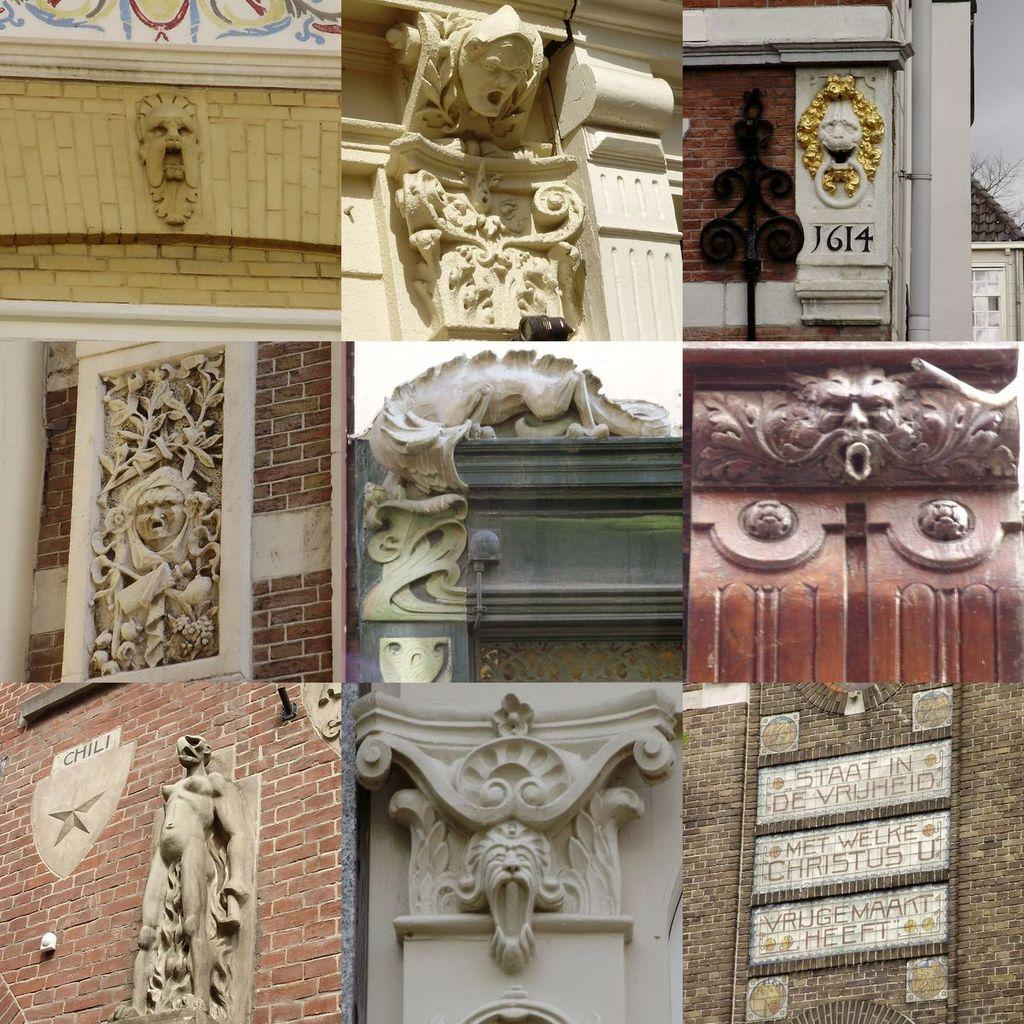What type of artwork is featured in the image? There are collages of photos and sculptures on the wall in the image. Can you describe the text on the wall in the image? Yes, there is text on the wall in the image. What type of hat is the toad wearing in the image? There is no toad or hat present in the image. What does the chin of the person in the image look like? There is no person present in the image, so it is not possible to describe their chin. 